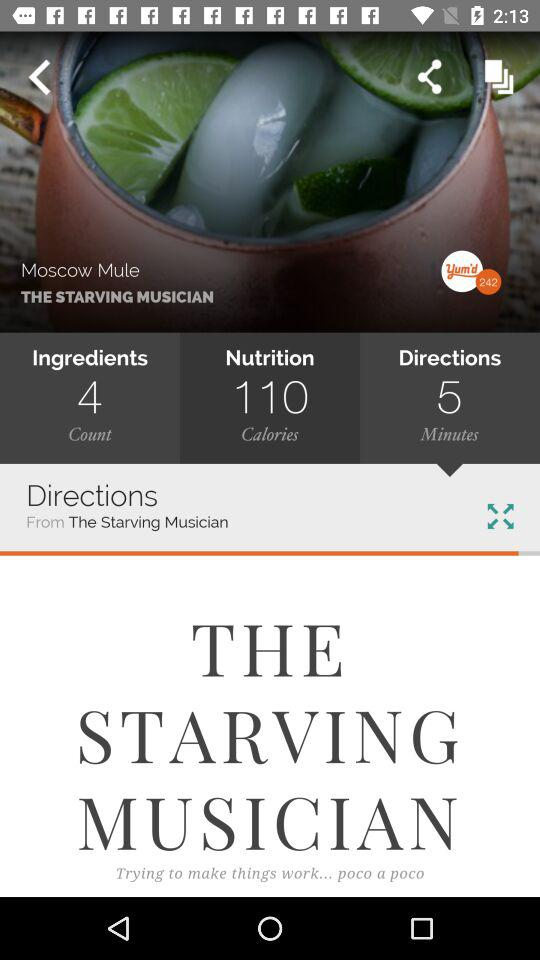What is the number of ingredients? The number of ingredients is 4. 